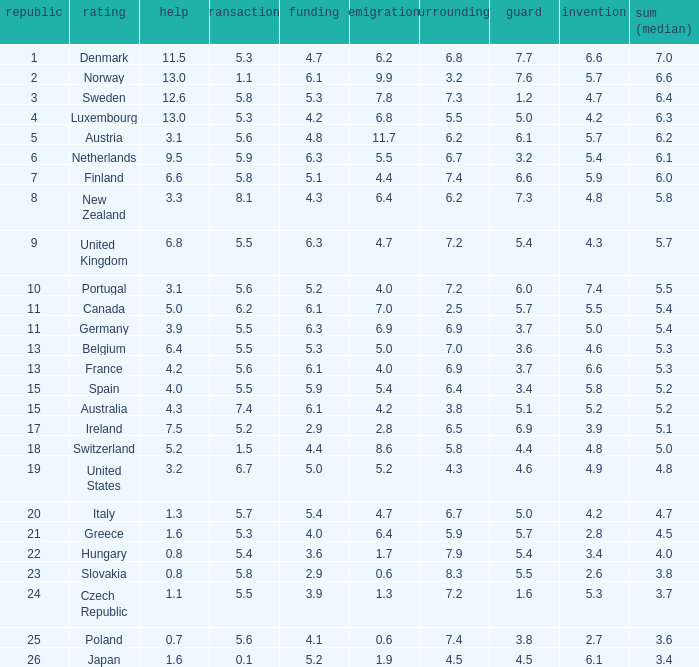What is the migration rating when trade is 5.7? 4.7. 